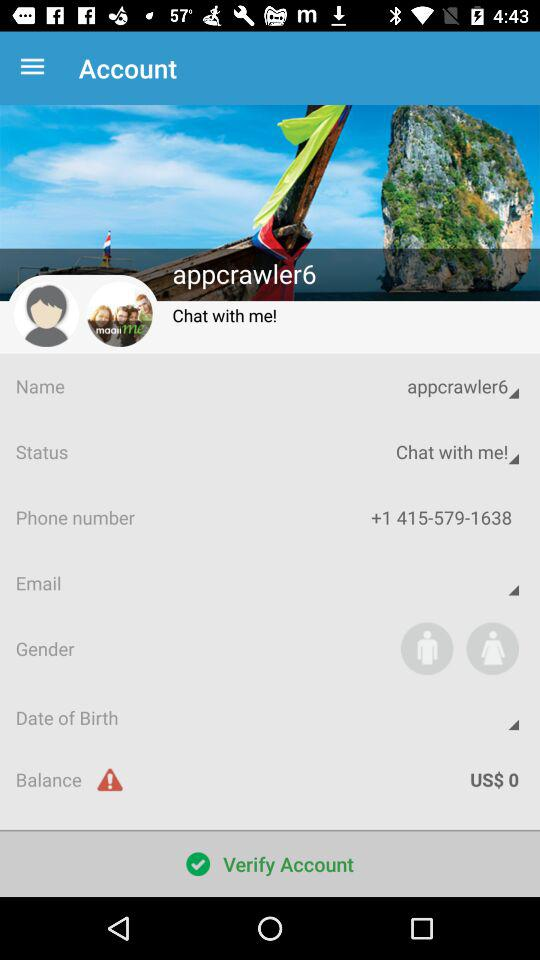What is the phone number? The phone number is +1 415-579-1638. 